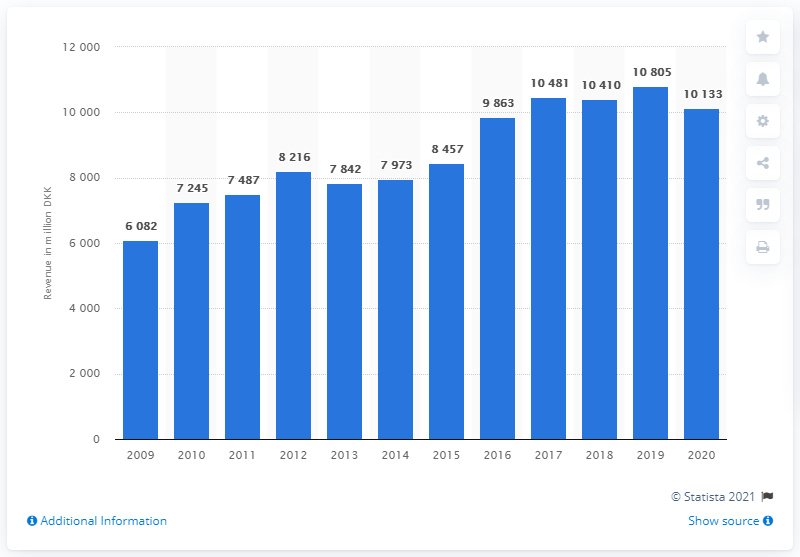Specify some key components in this picture. In 2009, the revenue of Leo Pharma A/S was 108,050. In the year 2019, the revenue of Leo Pharma A/S was 10,805. 